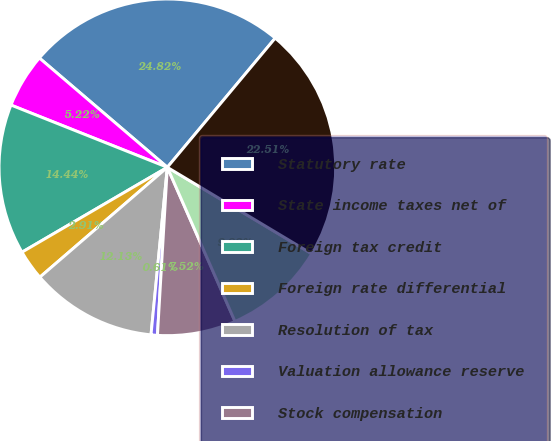Convert chart. <chart><loc_0><loc_0><loc_500><loc_500><pie_chart><fcel>Statutory rate<fcel>State income taxes net of<fcel>Foreign tax credit<fcel>Foreign rate differential<fcel>Resolution of tax<fcel>Valuation allowance reserve<fcel>Stock compensation<fcel>Other<fcel>Effective rate<nl><fcel>24.82%<fcel>5.22%<fcel>14.44%<fcel>2.91%<fcel>12.13%<fcel>0.61%<fcel>7.52%<fcel>9.83%<fcel>22.51%<nl></chart> 